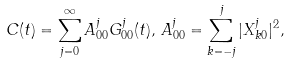<formula> <loc_0><loc_0><loc_500><loc_500>C ( t ) = \sum _ { j = 0 } ^ { \infty } A _ { 0 0 } ^ { j } G _ { 0 0 } ^ { j } ( t ) , \, A _ { 0 0 } ^ { j } = \sum _ { k = - j } ^ { j } | X _ { k 0 } ^ { j } | ^ { 2 } ,</formula> 